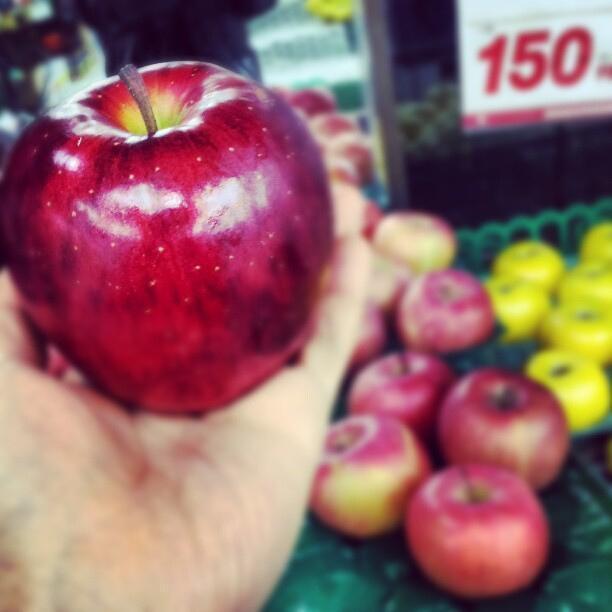How many apples are visible?
Give a very brief answer. 8. How many people are wearing an orange shirt?
Give a very brief answer. 0. 